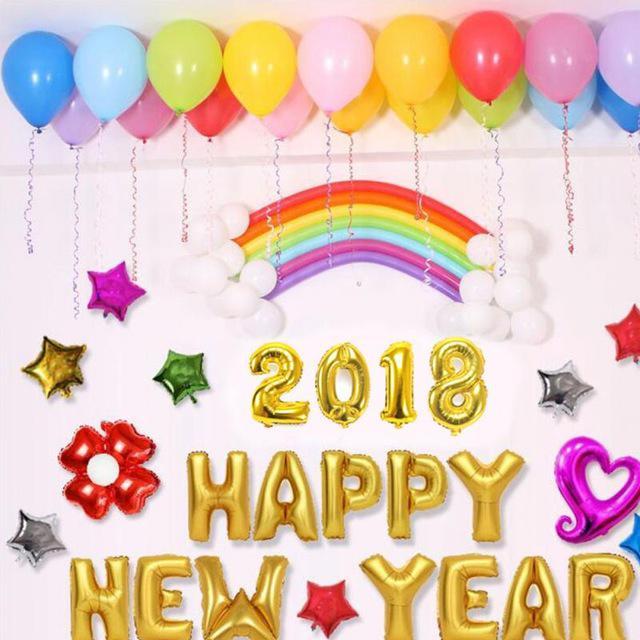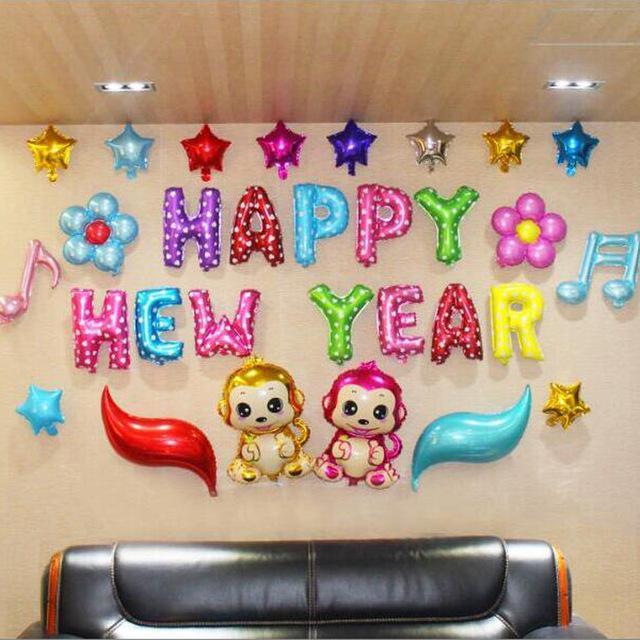The first image is the image on the left, the second image is the image on the right. Evaluate the accuracy of this statement regarding the images: "Some balloons have faces.". Is it true? Answer yes or no. Yes. The first image is the image on the left, the second image is the image on the right. Assess this claim about the two images: "Both images have letters.". Correct or not? Answer yes or no. Yes. 